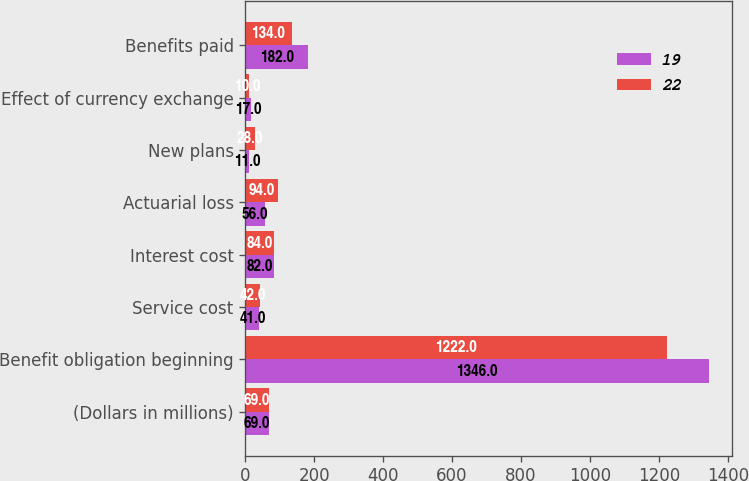Convert chart to OTSL. <chart><loc_0><loc_0><loc_500><loc_500><stacked_bar_chart><ecel><fcel>(Dollars in millions)<fcel>Benefit obligation beginning<fcel>Service cost<fcel>Interest cost<fcel>Actuarial loss<fcel>New plans<fcel>Effect of currency exchange<fcel>Benefits paid<nl><fcel>19<fcel>69<fcel>1346<fcel>41<fcel>82<fcel>56<fcel>11<fcel>17<fcel>182<nl><fcel>22<fcel>69<fcel>1222<fcel>42<fcel>84<fcel>94<fcel>28<fcel>10<fcel>134<nl></chart> 